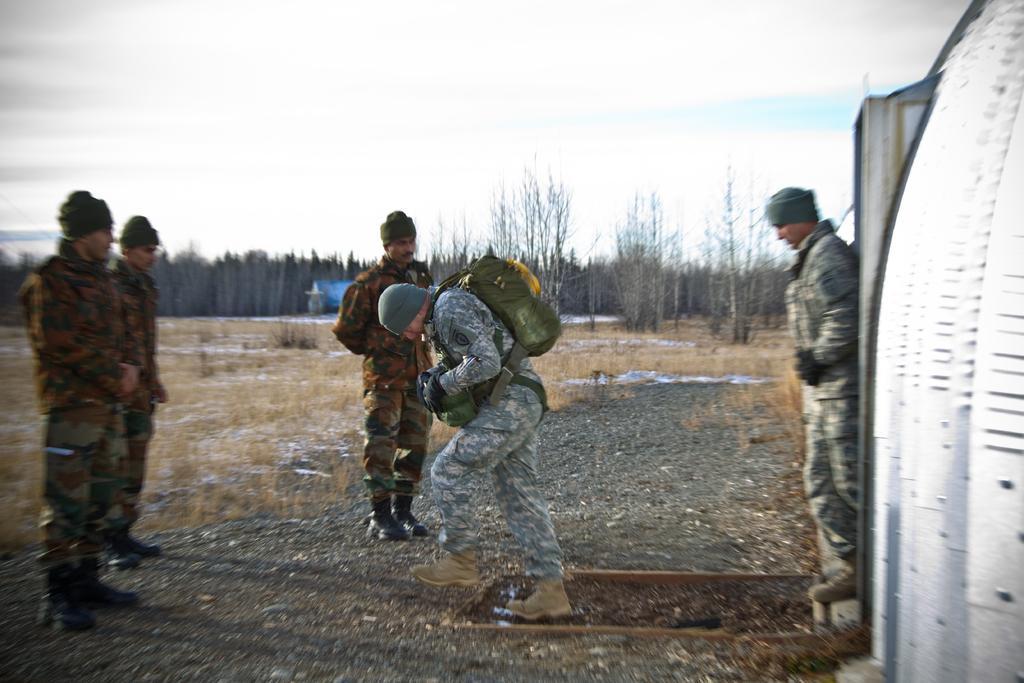Please provide a concise description of this image. This is an outside view. Here I can see five men wearing uniform and standing on the ground. One man is wearing a bag, holding an object in the hands, looking at the downwards and walking. In the background there are trees. On the right side there is a vehicle. At the top of the image I can see the sky. 